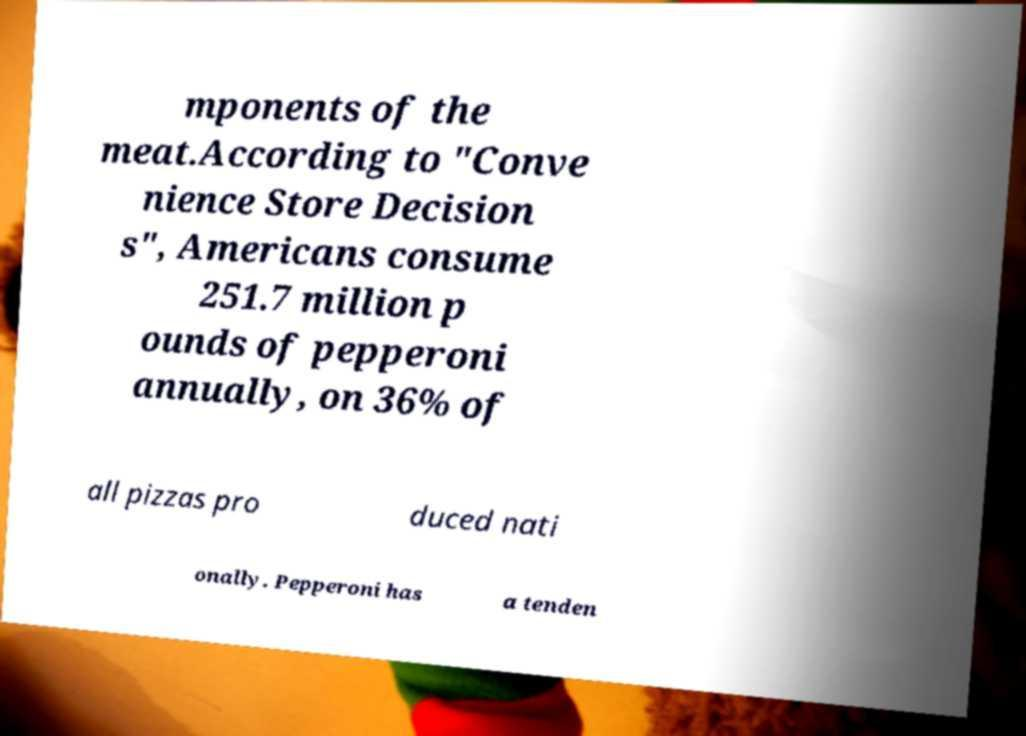Can you read and provide the text displayed in the image?This photo seems to have some interesting text. Can you extract and type it out for me? mponents of the meat.According to "Conve nience Store Decision s", Americans consume 251.7 million p ounds of pepperoni annually, on 36% of all pizzas pro duced nati onally. Pepperoni has a tenden 